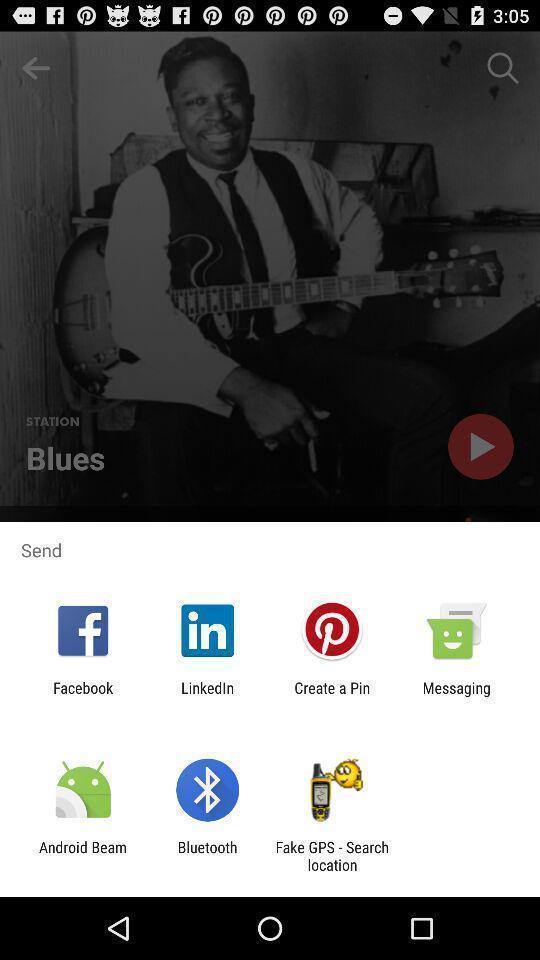Explain the elements present in this screenshot. Popup showing different apps to send. 